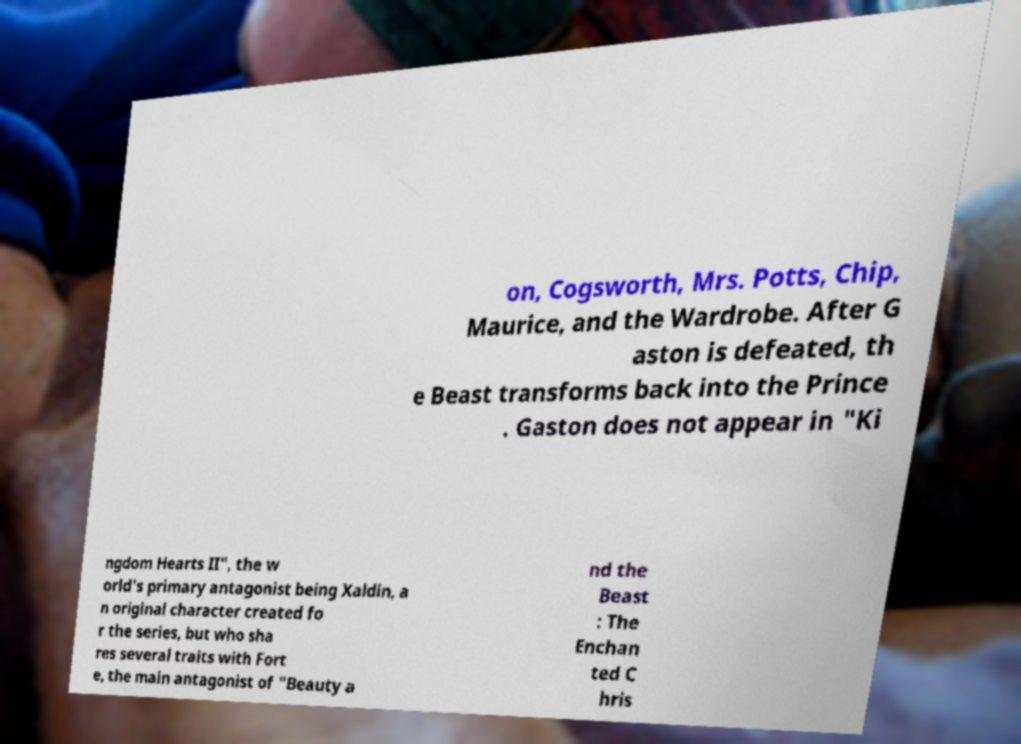Could you extract and type out the text from this image? on, Cogsworth, Mrs. Potts, Chip, Maurice, and the Wardrobe. After G aston is defeated, th e Beast transforms back into the Prince . Gaston does not appear in "Ki ngdom Hearts II", the w orld's primary antagonist being Xaldin, a n original character created fo r the series, but who sha res several traits with Fort e, the main antagonist of "Beauty a nd the Beast : The Enchan ted C hris 